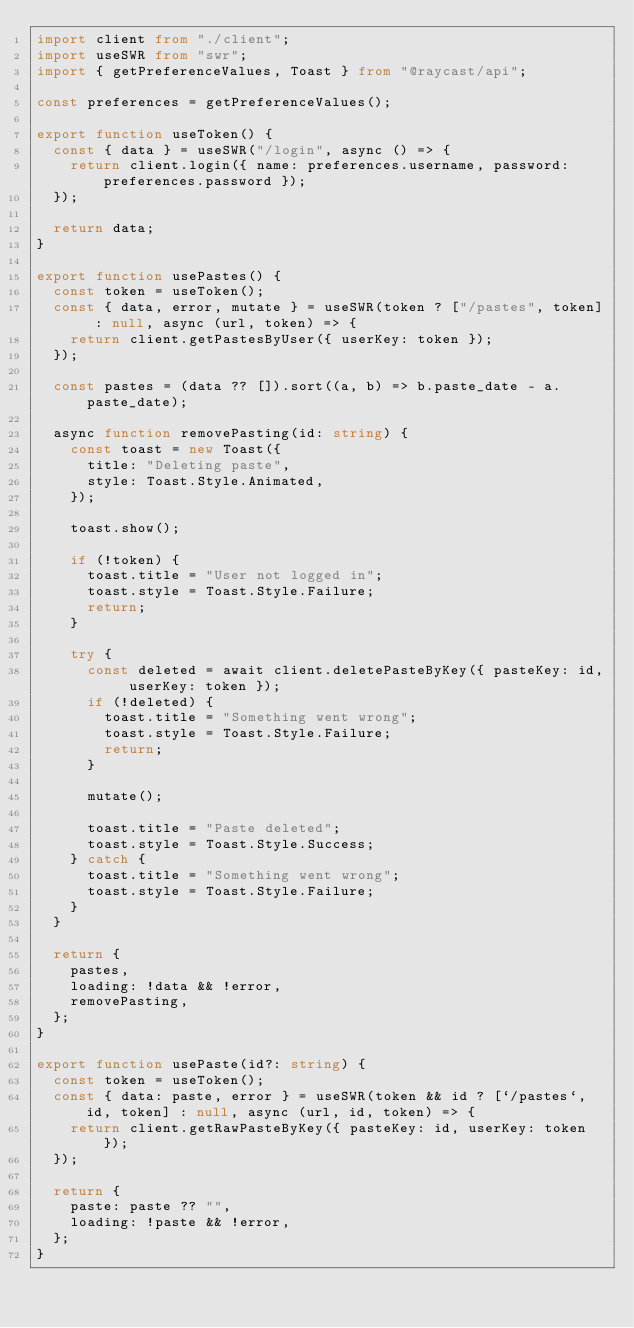<code> <loc_0><loc_0><loc_500><loc_500><_TypeScript_>import client from "./client";
import useSWR from "swr";
import { getPreferenceValues, Toast } from "@raycast/api";

const preferences = getPreferenceValues();

export function useToken() {
  const { data } = useSWR("/login", async () => {
    return client.login({ name: preferences.username, password: preferences.password });
  });

  return data;
}

export function usePastes() {
  const token = useToken();
  const { data, error, mutate } = useSWR(token ? ["/pastes", token] : null, async (url, token) => {
    return client.getPastesByUser({ userKey: token });
  });

  const pastes = (data ?? []).sort((a, b) => b.paste_date - a.paste_date);

  async function removePasting(id: string) {
    const toast = new Toast({
      title: "Deleting paste",
      style: Toast.Style.Animated,
    });

    toast.show();

    if (!token) {
      toast.title = "User not logged in";
      toast.style = Toast.Style.Failure;
      return;
    }

    try {
      const deleted = await client.deletePasteByKey({ pasteKey: id, userKey: token });
      if (!deleted) {
        toast.title = "Something went wrong";
        toast.style = Toast.Style.Failure;
        return;
      }

      mutate();

      toast.title = "Paste deleted";
      toast.style = Toast.Style.Success;
    } catch {
      toast.title = "Something went wrong";
      toast.style = Toast.Style.Failure;
    }
  }

  return {
    pastes,
    loading: !data && !error,
    removePasting,
  };
}

export function usePaste(id?: string) {
  const token = useToken();
  const { data: paste, error } = useSWR(token && id ? [`/pastes`, id, token] : null, async (url, id, token) => {
    return client.getRawPasteByKey({ pasteKey: id, userKey: token });
  });

  return {
    paste: paste ?? "",
    loading: !paste && !error,
  };
}
</code> 